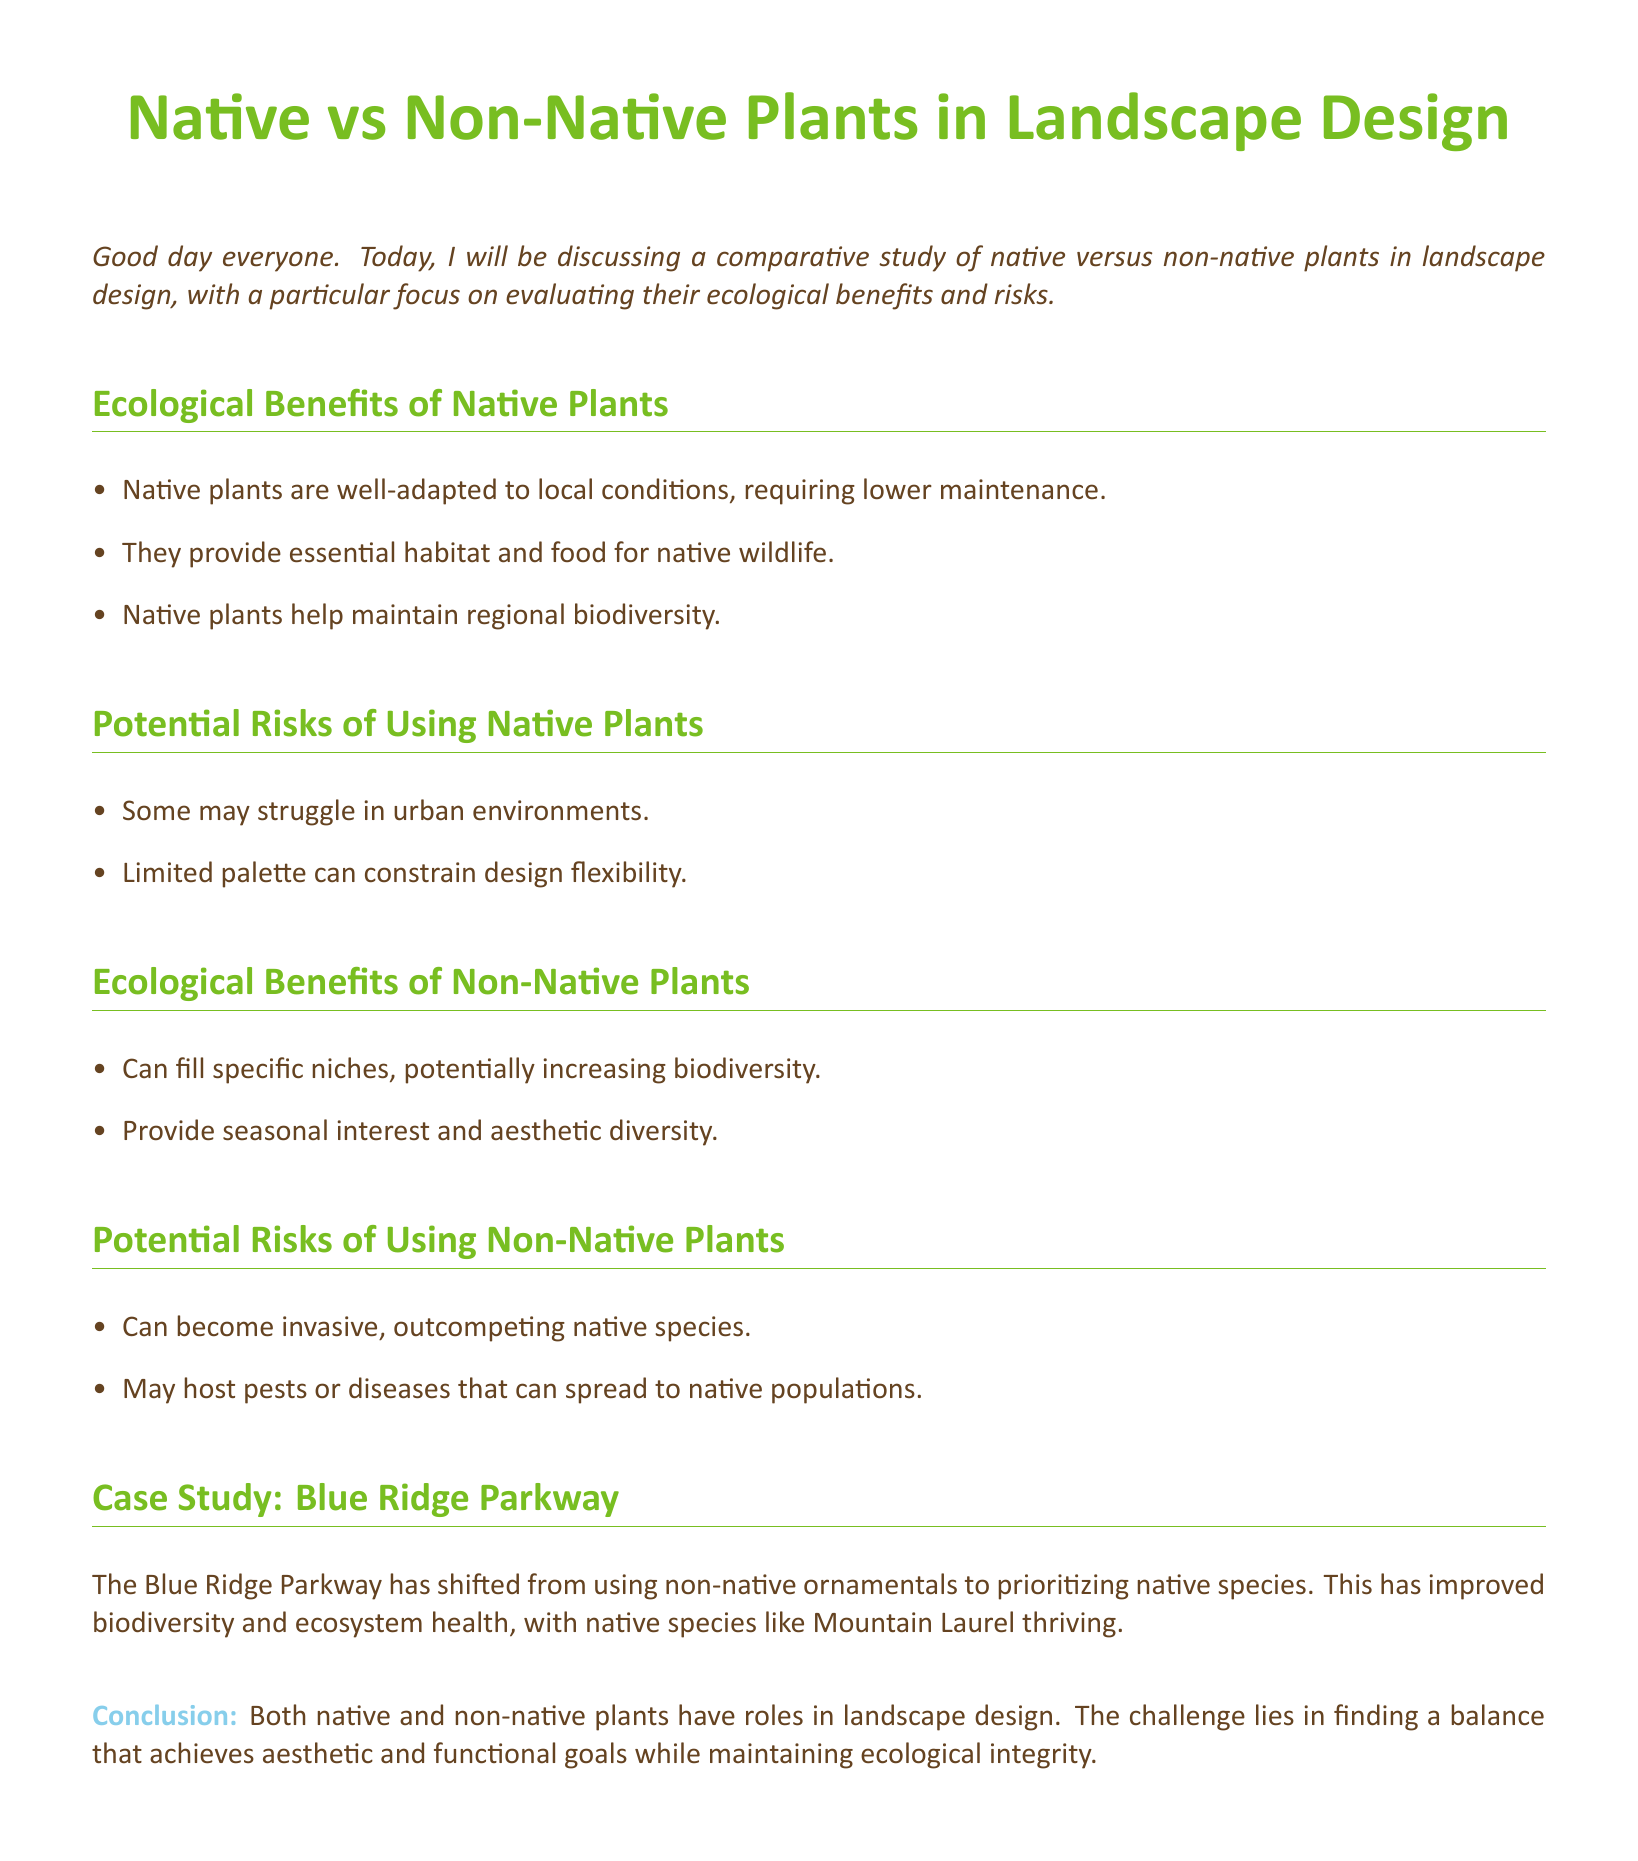What are the ecological benefits of native plants? The document lists the ecological benefits of native plants, which are lower maintenance, essential habitat for wildlife, and maintaining biodiversity.
Answer: Lower maintenance, habitat and food for wildlife, maintaining biodiversity What are the potential risks of using native plants? The document outlines potential risks, including struggles in urban environments and limited design flexibility.
Answer: Struggles in urban environments, limited palette What type of plants can increase biodiversity? The document states that non-native plants can fill specific niches and potentially increase biodiversity.
Answer: Non-native plants What is the case study mentioned in the document? The case study presented in the document focuses on the Blue Ridge Parkway and its shift towards native species use.
Answer: Blue Ridge Parkway What has improved in the Blue Ridge Parkway according to the case study? The document notes that the shift to native species has improved biodiversity and ecosystem health.
Answer: Biodiversity and ecosystem health What is a risk associated with non-native plants? One risk mentioned is that non-native plants can become invasive and outcompete native species.
Answer: Invasive What color is used to define environmental benefits in the document? The color used for environmental benefits in the section headers and throughout the document is leaf green.
Answer: Leaf green What type of approach does the conclusion suggest for landscape design? The conclusion suggests balancing aesthetic and functional goals while maintaining ecological integrity.
Answer: Balancing aesthetic and functional goals What type of species is thriving in the Blue Ridge Parkway? The document indicates that native species like Mountain Laurel are thriving in the Blue Ridge Parkway.
Answer: Mountain Laurel 